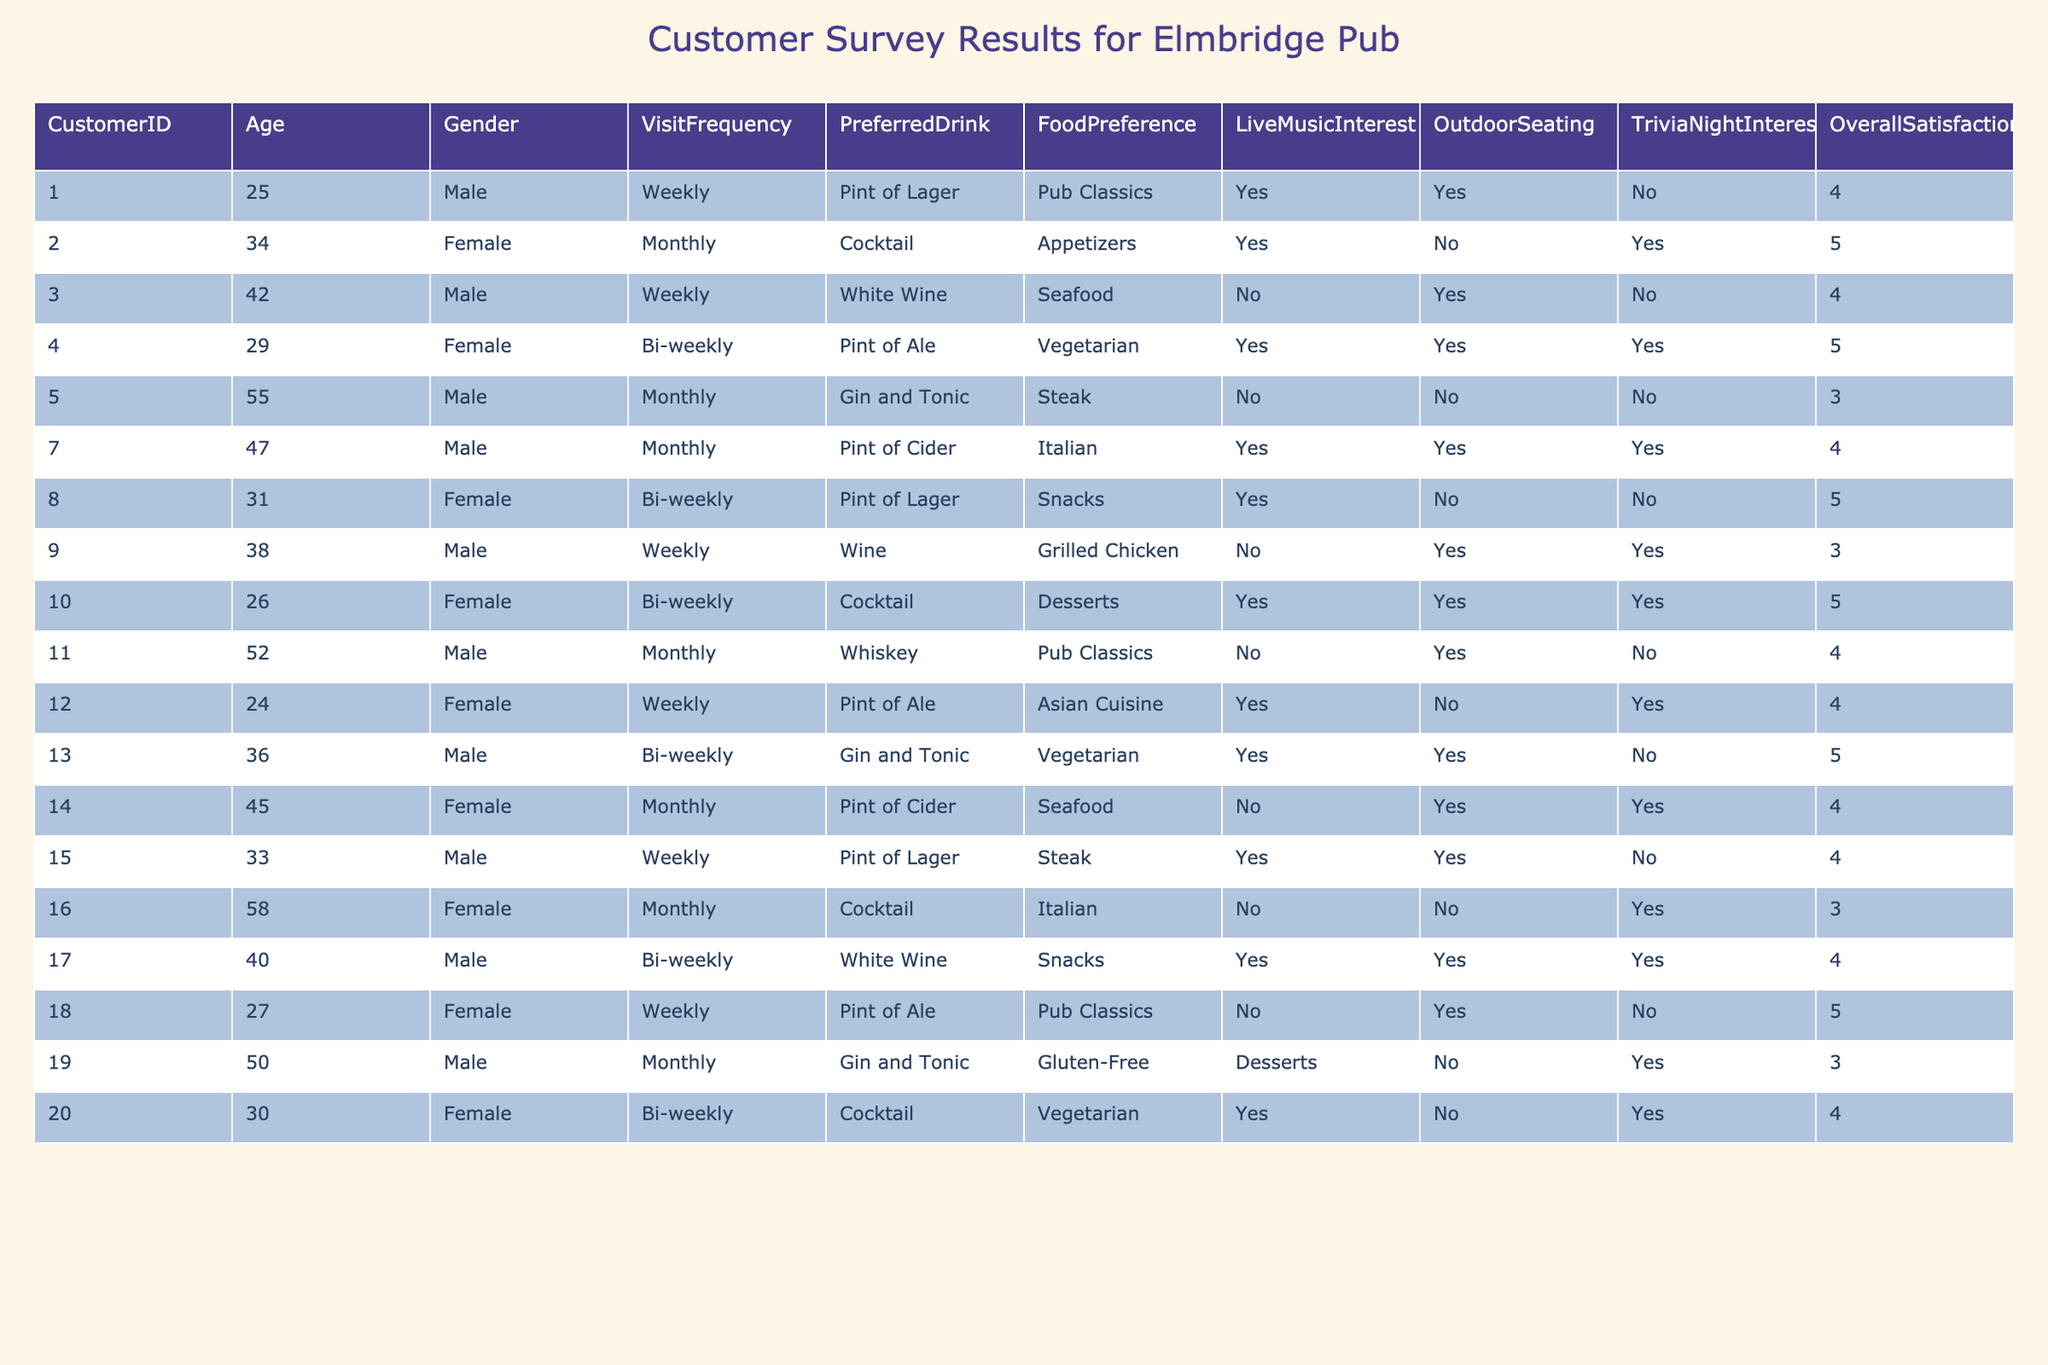What is the overall satisfaction score of the customer who visits weekly and prefers a pint of lager? From the table, I locate the entry for the customer who visits weekly and prefers a pint of lager, which corresponds to Customer 1. Their overall satisfaction score is 4.
Answer: 4 What percentage of customers expressed an interest in live music? Out of the 20 customers, 10 indicated they were interested in live music (listening 'Yes'). Thus, the percentage is (10/20) * 100 = 50%.
Answer: 50% What is the most preferred drink among customers? Looking for the drink preferences, 'Pint of Lager' appears 4 times, more than any other drink. Thus, it is the most preferred drink.
Answer: Pint of Lager How many customers have an overall satisfaction score of 5? I count the rows in the table where the overall satisfaction is 5. There are 6 customers that achieved this score.
Answer: 6 Is there a correlation between outdoor seating interest and higher overall satisfaction? Customers who expressed interest in outdoor seating show a mix of satisfaction scores, ranging from 3 to 5. The average satisfaction for those interested is slightly higher than those who aren't, but both groups have a range. Thus, I conclude there isn't a clear correlation.
Answer: No What is the average overall satisfaction score for female customers? I add the overall satisfaction scores of female customers: 5, 5, 4, 3, 5, 4, and 4, giving a total of 30. Dividing by the number of female customers (7) results in an average of 30/7 = approximately 4.29.
Answer: 4.29 Which food preference category had the highest satisfaction score? The food preferences are varied; I check each category to see satisfaction averages. 'Vegetarian' has two scores of 5, and 'Pub Classics' shows a score of 5 as well. Thus, both categories tie for the highest score.
Answer: Vegetarian and Pub Classics How many customers visit the pub weekly? I scan the VisitFrequency column for the term 'Weekly' and find 6 customers who visit weekly based on the entries in the table.
Answer: 6 What is the average age of customers with an interest in trivia nights? First, I find customers interested in trivia nights. There are 5 customers (IDs: 2, 4, 10, and 12) aged 34, 29, 26, and 24, respectively. The total age is 34 + 29 + 26 + 24 = 113, and dividing by 4 yields an average age of roughly 28.25.
Answer: 28.25 How many customers expressed an interest in outdoor seating for food preferences categorized as 'Snacks'? Upon checking the food preferences, 3 customers with 'Snacks' (Customer ID 8, 17, and 9) expressed interest in outdoor seating.
Answer: 3 Is there a customer who enjoys seafood yet has a satisfaction score of 3? Looking through those who prefer seafood, I identify Customer 5 has a satisfaction score of 3, confirming this statement to be true.
Answer: Yes 